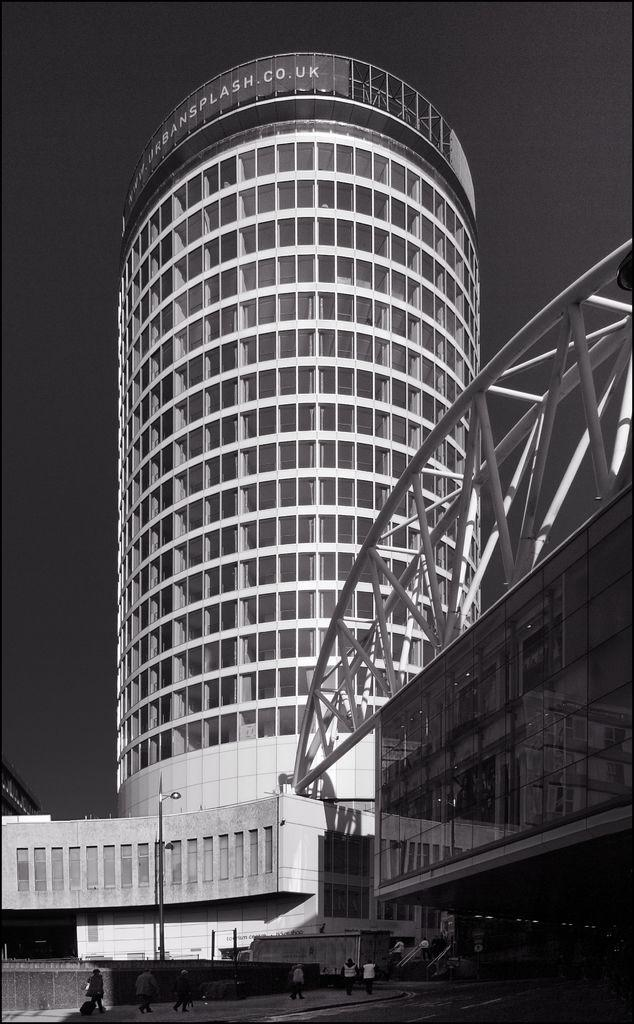What type of structures are present in the image? There are buildings in the image. What materials are used in the construction of the buildings? The buildings have glass windows and metal frames. Can you describe the people visible in the image? There are people visible in the image. What type of lighting is present in the image? There is a street light in the image. What is visible at the top of the image? The sky is visible at the top of the image. What type of team is playing in the image? There is no team playing in the image; it features buildings, people, and a street light. What kind of experience can be gained from the place shown in the image? There is no specific place shown in the image, just buildings, people, and a street light. 